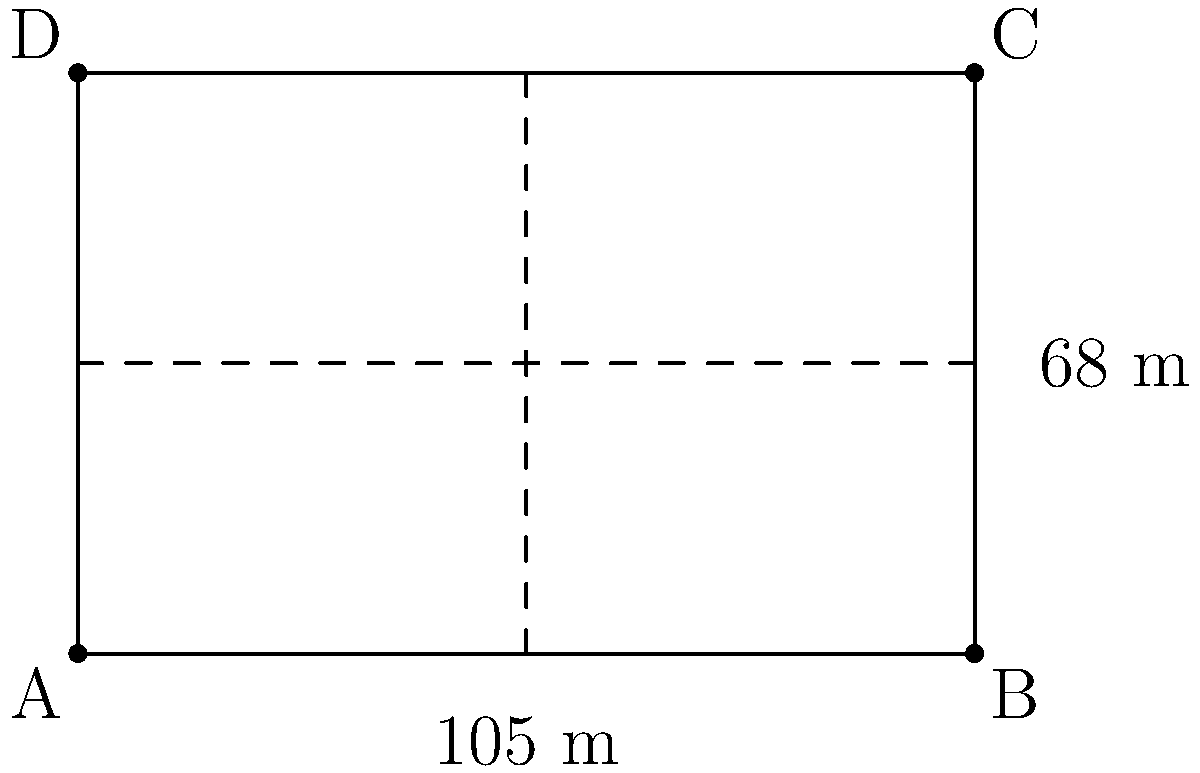As a fan of the Korean football league, you're curious about the dimensions of the standard soccer field used in the K League 1. Given that the field is rectangular with a length of 105 meters and a width of 68 meters, calculate the total area of the playing surface. Express your answer in square meters. To calculate the area of a rectangular soccer field, we need to multiply its length by its width. Let's break it down step-by-step:

1. Identify the given dimensions:
   - Length = 105 meters
   - Width = 68 meters

2. Use the formula for the area of a rectangle:
   $$ A = l \times w $$
   Where $A$ is the area, $l$ is the length, and $w$ is the width.

3. Substitute the known values into the formula:
   $$ A = 105 \text{ m} \times 68 \text{ m} $$

4. Perform the multiplication:
   $$ A = 7,140 \text{ m}^2 $$

Therefore, the total area of the K League 1 standard soccer field is 7,140 square meters.
Answer: 7,140 m² 